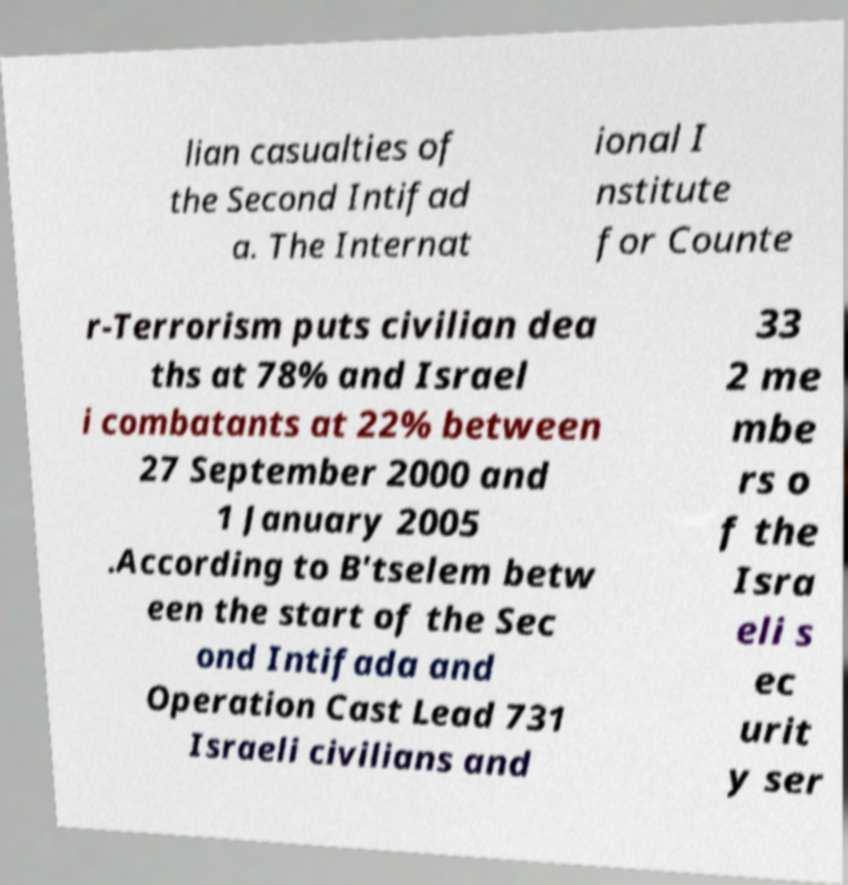Please identify and transcribe the text found in this image. lian casualties of the Second Intifad a. The Internat ional I nstitute for Counte r-Terrorism puts civilian dea ths at 78% and Israel i combatants at 22% between 27 September 2000 and 1 January 2005 .According to B'tselem betw een the start of the Sec ond Intifada and Operation Cast Lead 731 Israeli civilians and 33 2 me mbe rs o f the Isra eli s ec urit y ser 